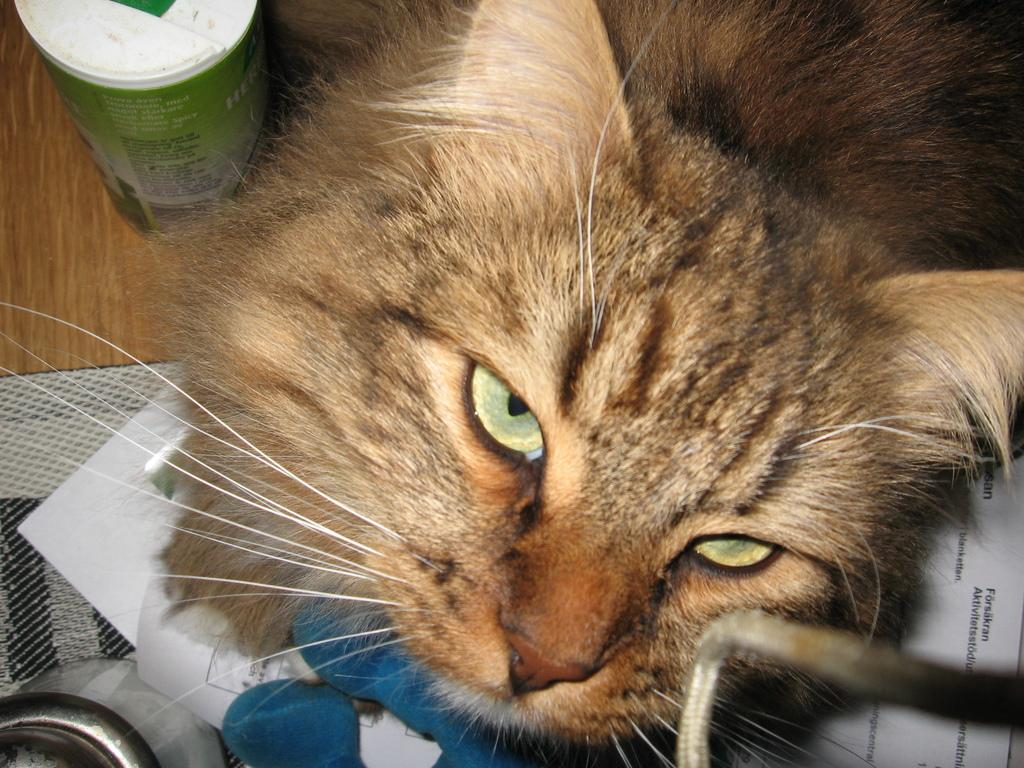What type of animal can be seen in the image? There is a cat in the image. What is the cat sitting on in the image? The cat is sitting on a wooden platform in the image. What else can be seen on the wooden platform? There are papers in the image. Can you describe any other objects in the image? Yes, there are some objects in the image. What type of cable can be seen connecting the cat to the wooden platform in the image? There is no cable connecting the cat to the wooden platform in the image. 